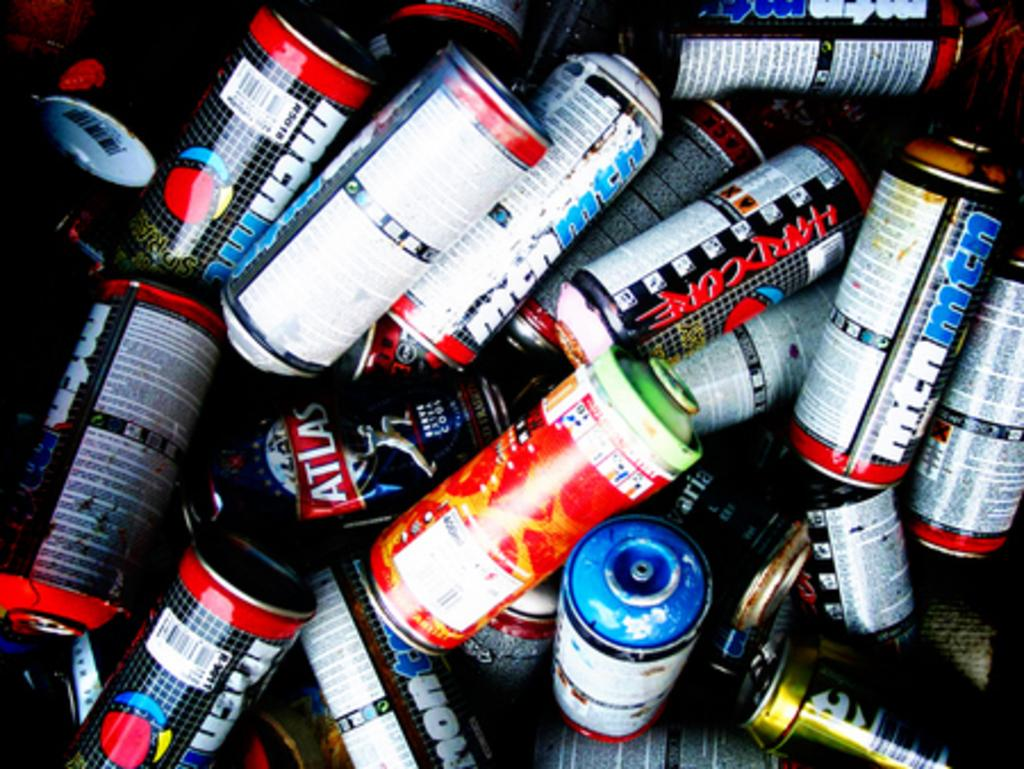<image>
Summarize the visual content of the image. A lot of cans in a pile and one says "Hardcore". 